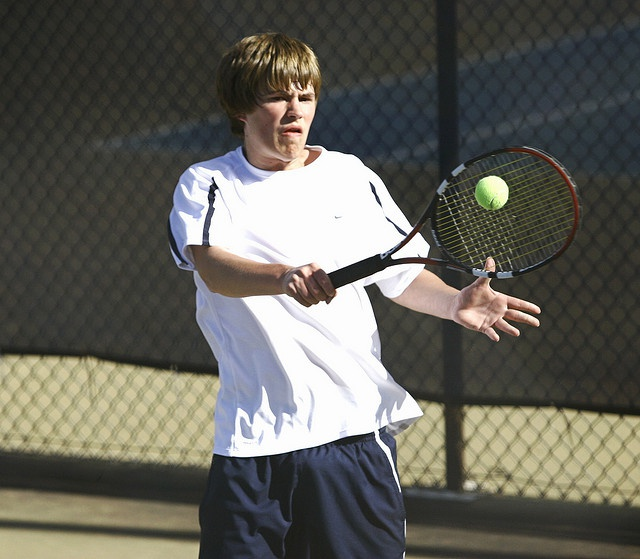Describe the objects in this image and their specific colors. I can see people in black, white, darkgray, and gray tones, tennis racket in black, darkgreen, gray, and ivory tones, and sports ball in black, lightyellow, khaki, green, and lightgreen tones in this image. 